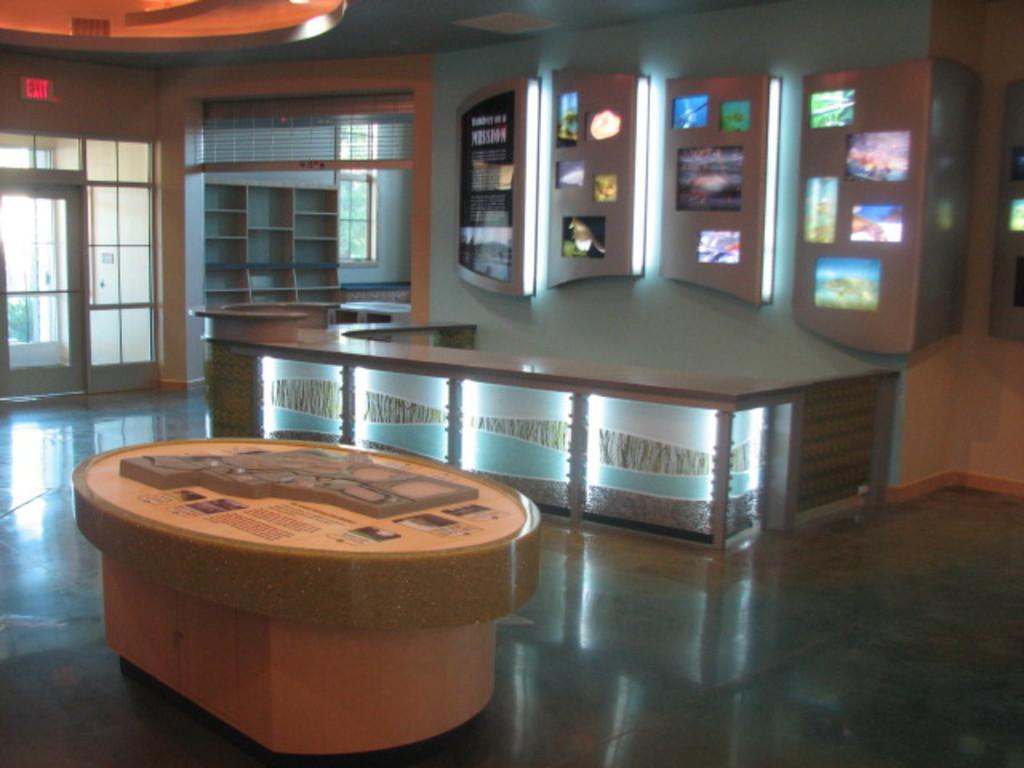Can you describe this image briefly? In this picture I can see the round table, beside that I can see U-shaped table. On the right I can see the tube-light and screen which are placed on the wall. On the left I can see the wooden shelves, windows and doors. In the top left corner there is an exit sign board. Through the windows I can see the trees. 